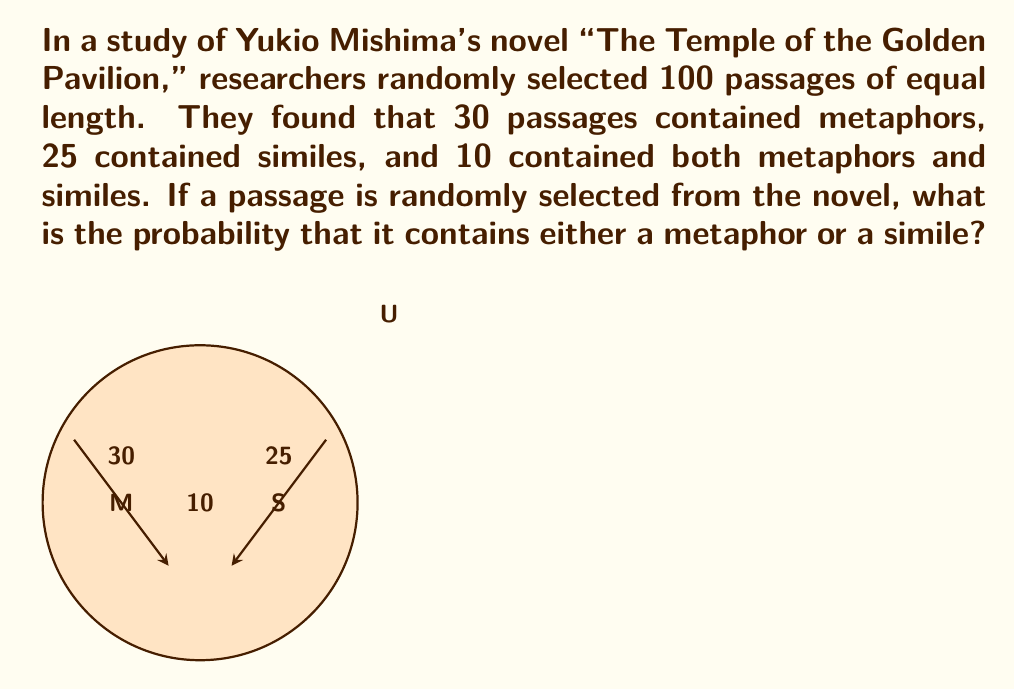Show me your answer to this math problem. Let's approach this step-by-step using set theory and probability:

1) Let M be the event of selecting a passage with a metaphor, and S be the event of selecting a passage with a simile.

2) We're given:
   P(M) = 30/100 = 0.3
   P(S) = 25/100 = 0.25
   P(M ∩ S) = 10/100 = 0.1

3) We need to find P(M ∪ S), the probability of selecting a passage with either a metaphor or a simile (or both).

4) We can use the addition rule of probability:
   P(M ∪ S) = P(M) + P(S) - P(M ∩ S)

5) Substituting the values:
   P(M ∪ S) = 0.3 + 0.25 - 0.1

6) Calculating:
   P(M ∪ S) = 0.45

Therefore, the probability of randomly selecting a passage that contains either a metaphor or a simile is 0.45 or 45%.
Answer: 0.45 